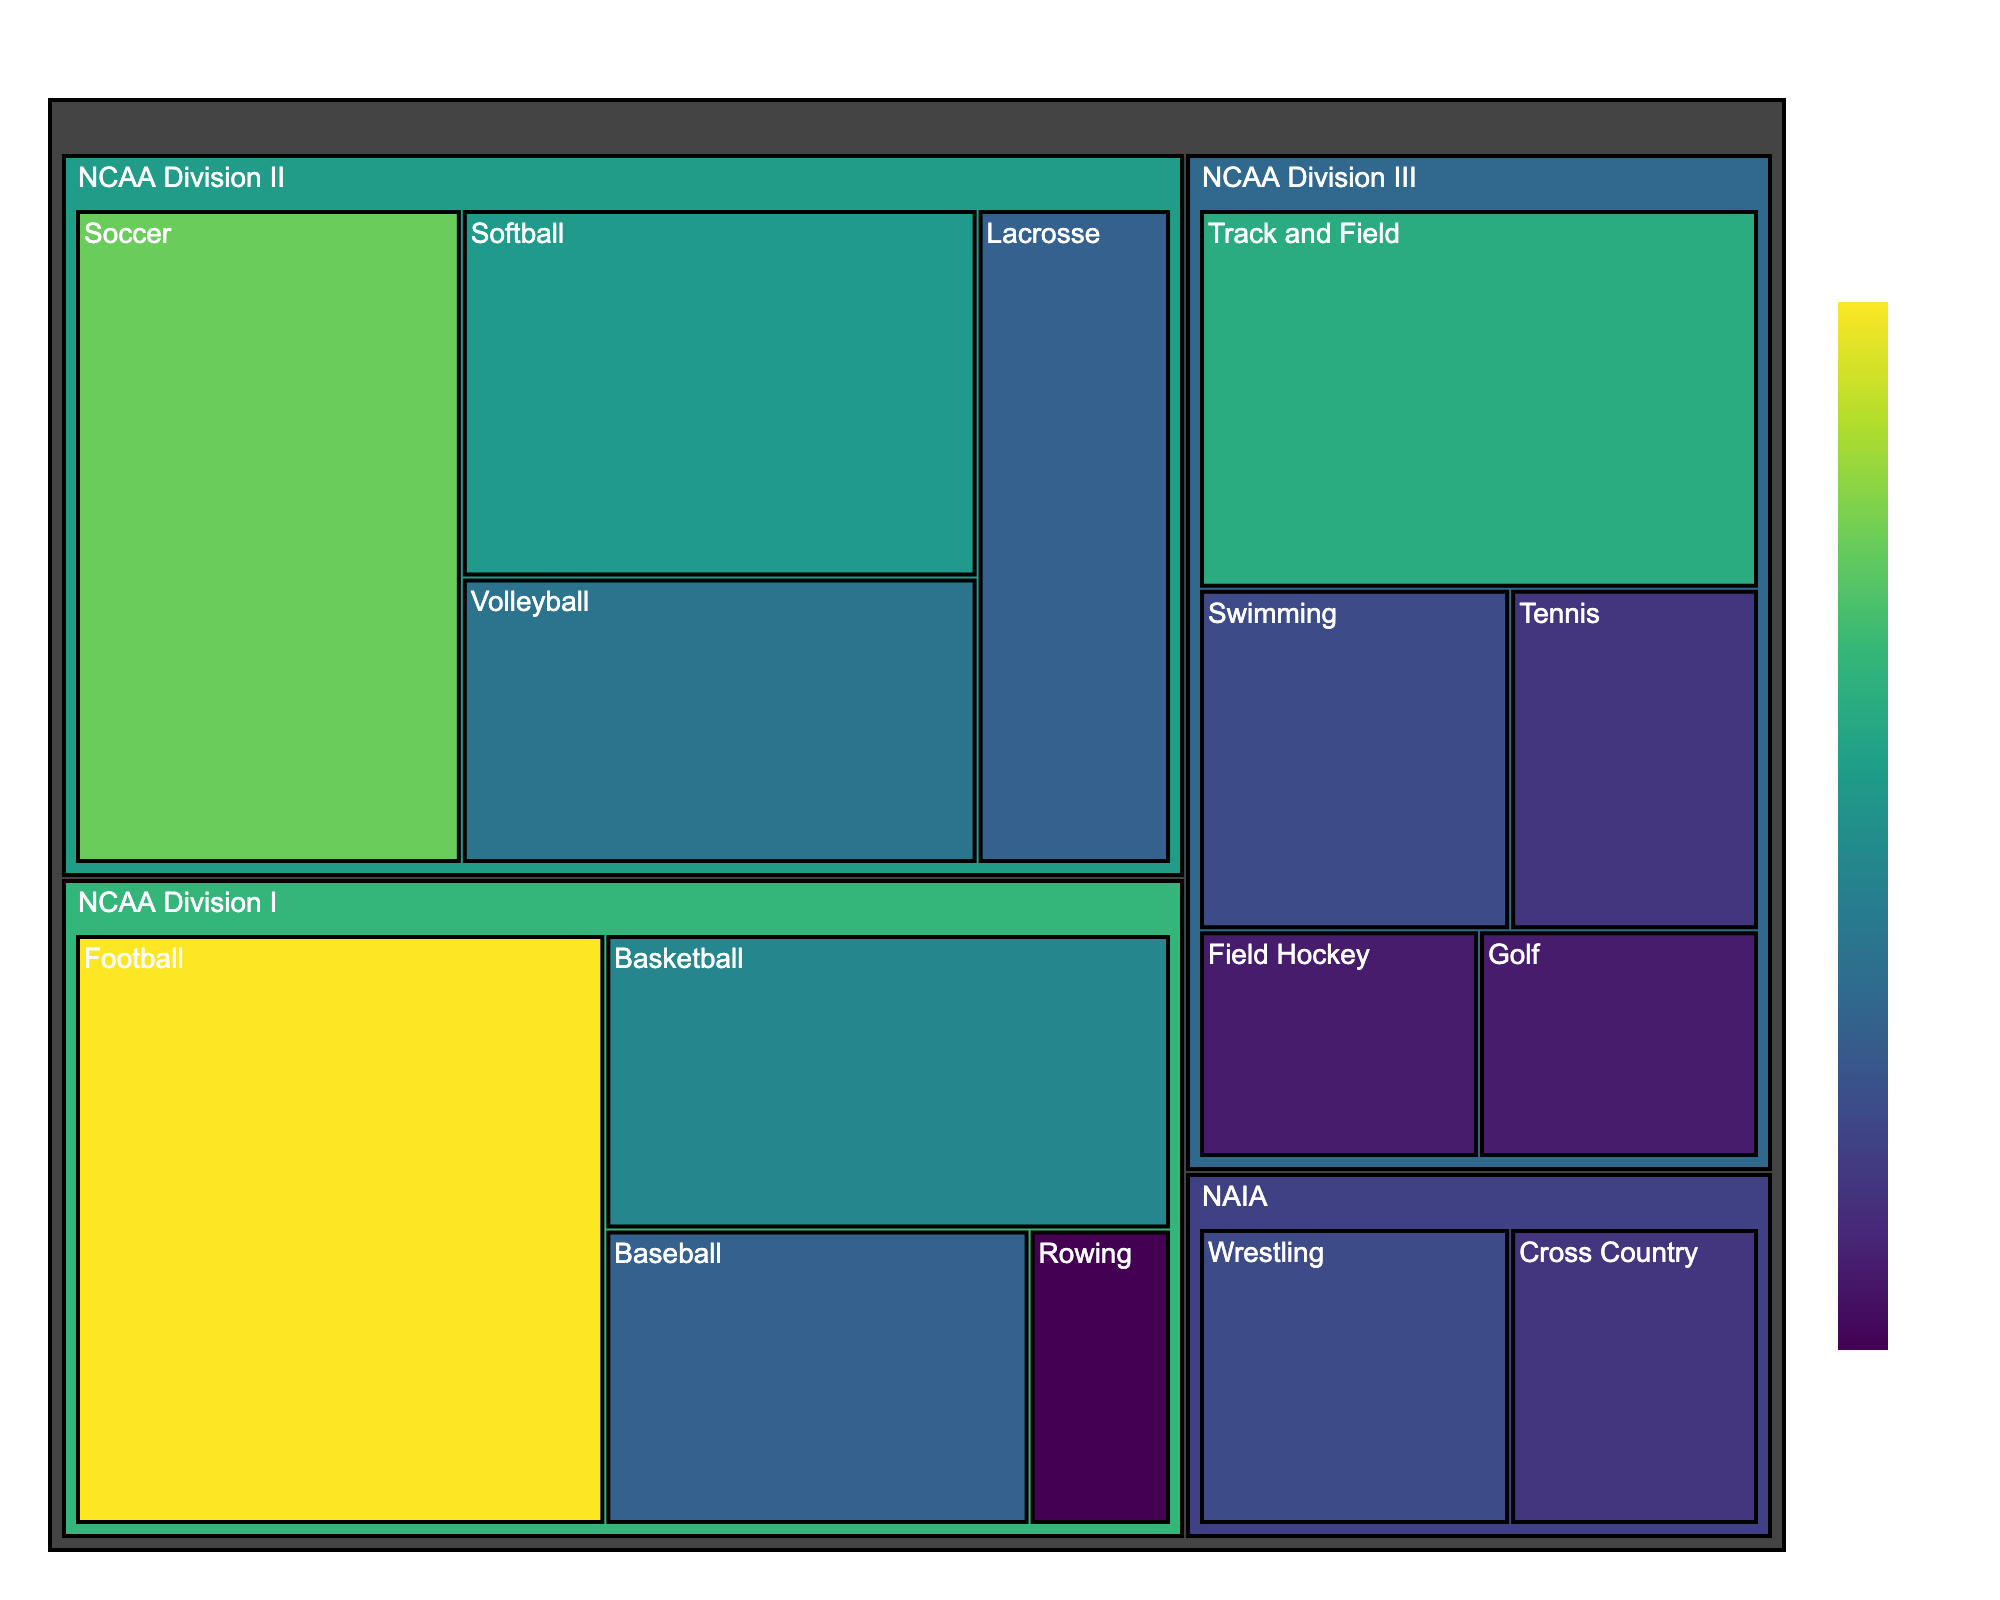What is the total number of athletic scholarships awarded to Lake County high school athletes? To find the total number of athletic scholarships awarded, sum up all the values from each sport and division. This includes all scholarships shown in the figure.
Answer: 99 Which sport received the most athletic scholarships? Look at the different sports listed in the treemap and identify the one with the highest number of scholarships.
Answer: Football How many scholarships were awarded for NCAA Division I sports? Sum the number of scholarships for each sport under the NCAA Division I division in the treemap.
Answer: 31 Which division has the fewest scholarships awarded in total? Compare the total number of scholarships across NCAA Division I, NCAA Division II, NCAA Division III, and NAIA. Identify the division with the smallest number.
Answer: NAIA How many scholarships were awarded for sports in NCAA Division II? Add the number of scholarships for each sport listed under NCAA Division II.
Answer: 34 Of the sports listed under NCAA Division III, which sport received the fewest scholarships? Look at the number of scholarships under NCAA Division III and find the sport with the lowest number.
Answer: Golf and Field Hockey How many more scholarships were awarded to Soccer than Wrestling? Calculate the difference in the number of scholarships between Soccer (NCAA Division II) and Wrestling (NAIA).
Answer: 7 Which division awards the highest number of scholarships for individual sports combined? Compare the total number of scholarships for NCAA Division I, NCAA Division II, NCAA Division III, and NAIA based on a combined count of all individual sports listed in the division.
Answer: NCAA Division III Which sports have an equal number of scholarships awarded within their respective divisions? Find sports within various divisions that have the same number of scholarships awarded, such as Lacrosse and Baseball within different divisions.
Answer: Lacrosse (NCAA Division II) and Baseball (NCAA Division I) with 6 scholarships each What is the average number of scholarships awarded per sport in NCAA Division III? Divide the total number of scholarships under NCAA Division III by the number of sports listed under this division.
Answer: 5.5 